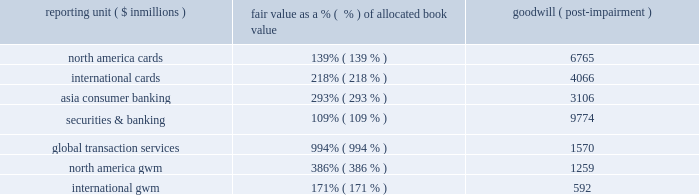Banking ) .
The results of the first step of the impairment test showed no indication of impairment in any of the reporting units at any of the periods except december 31 , 2008 and , accordingly , the company did not perform the second step of the impairment test , except for the test performed as of december 31 , 2008 .
As of december 31 , 2008 , there was an indication of impairment in the north america consumer banking , latin america consumer banking and emea consumer banking reporting units and , accordingly , the second step of testing was performed on these reporting units .
Based on the results of the second step of testing , the company recorded a $ 9.6 billion pretax ( $ 8.7 billion after tax ) goodwill impairment charge in the fourth quarter of 2008 , representing the entire amount of goodwill allocated to these reporting units .
The primary cause for the goodwill impairment in the above reporting units was the rapid deterioration in the financial markets , as well as in the global economic outlook particularly during the period beginning mid-november through year end 2008 .
This deterioration further weakened the near-term prospects for the financial services industry .
These and other factors , including the increased possibility of further government intervention , also resulted in the decline in the company 2019s market capitalization from approximately $ 90 billion at july 1 , 2008 and approximately $ 74 billion at october 31 , 2008 to approximately $ 36 billion at december 31 , 2008 .
The more significant fair-value adjustments in the pro forma purchase price allocation in the second step of testing were to fair-value loans and debt and were made to identify and value identifiable intangibles .
The adjustments to measure the assets , liabilities and intangibles were for the purpose of measuring the implied fair value of goodwill and such adjustments are not reflected in the consolidated balance sheet .
The table shows reporting units with goodwill balances and the excess of fair value of allocated book value as of december 31 , 2008 .
Reporting unit ( $ in millions ) fair value as a % (  % ) of allocated book value goodwill ( post-impairment ) .
While no impairment was noted in step one of our securities and banking reporting unit impairment test at october 31 , 2008 and december 31 , 2008 , goodwill present in that reporting unit may be particularly sensitive to further deterioration in economic conditions .
Under the market approach for valuing this reporting unit , the earnings multiples and transaction multiples were selected from multiples obtained using data from guideline companies and acquisitions .
The selection of the actual multiple considers operating performance and financial condition such as return on equity and net income growth of securities and banking as compared to the guideline companies and acquisitions .
For the valuation under the income approach , the company utilized a discount rate which it believes reflects the risk and uncertainty related to the projected cash flows , and selected 2013 as the terminal year .
In 2013 , the value was derived assuming a return to historical levels of core-business profitability for the reporting unit , despite the significant losses experienced in 2008 .
This assumption is based on management 2019s view that this recovery will occur based upon various macro- economic factors such as the recent u.s .
Government stimulus actions , restoring marketplace confidence and improved risk-management practices on an industry-wide basis .
Furthermore , company-specific actions such as its recently announced realignment of its businesses to optimize its global businesses for future profitable growth , will also be a factor in returning the company 2019s core securities and banking business to historical levels .
Small deterioration in the assumptions used in the valuations , in particular the discount rate and growth rate assumptions used in the net income projections , could significantly affect the company 2019s impairment evaluation and , hence , results .
If the future were to differ adversely from management 2019s best estimate of key economic assumptions and associated cash flows were to decrease by a small margin , the company could potentially experience future material impairment charges with respect to the goodwill remaining in our securities and banking reporting unit .
Any such charges by themselves would not negatively affect the company 2019s tier 1 and total regulatory capital ratios , tangible capital or the company 2019s liquidity position. .
In 2008 what was the tax rate associated with the goodwill impairment? 
Computations: ((9.6 - 8.7) / 8.7)
Answer: 0.10345. 